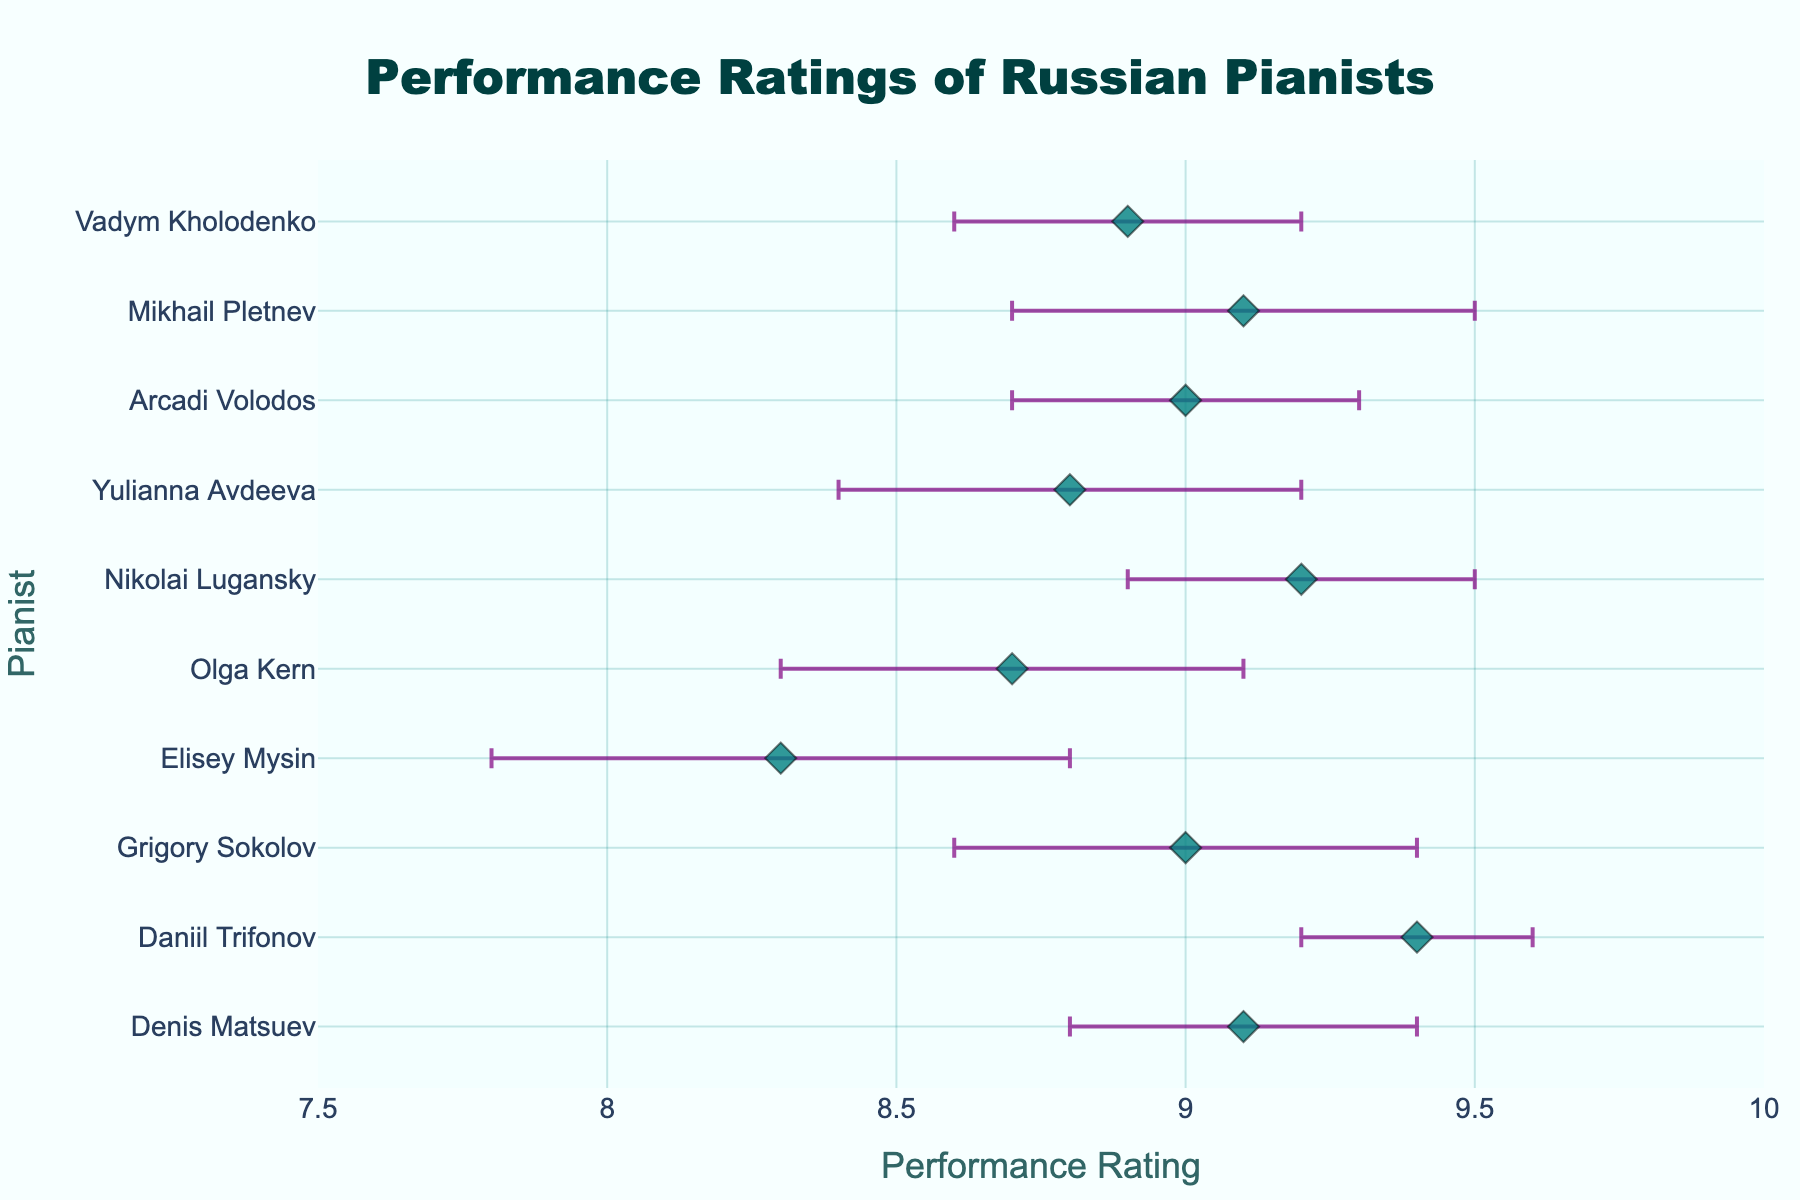What is the highest performance rating shown in the plot? The highest rating is the dot positioned farthest to the right on the x-axis. This corresponds to Daniil Trifonov with a performance rating of 9.4.
Answer: 9.4 Which pianist received the lowest performance rating? The dot farthest to the left on the x-axis indicates the lowest performance rating. This corresponds to Elisey Mysin, who has a performance rating of 8.3.
Answer: Elisey Mysin How many pianists have a performance rating above 9.0? By counting the dots to the right of the 9.0 mark on the x-axis, there are 6 pianists with ratings above 9.0: Denis Matsuev, Daniil Trifonov, Grigory Sokolov, Nikolai Lugansky, Arcadi Volodos, and Mikhail Pletnev.
Answer: 6 Who has the smallest standard deviation in their performance rating? The smallest standard deviation corresponds to the smallest error bar. This is seen with Daniil Trifonov, who has an error bar of 0.2.
Answer: Daniil Trifonov What is the range of performance ratings displayed in the plot? The range is calculated by subtracting the lowest rating (8.3 from Elisey Mysin) from the highest rating (9.4 from Daniil Trifonov), giving 9.4 - 8.3 = 1.1.
Answer: 1.1 Compare the performance ratings of Denis Matsuev and Nikolai Lugansky. Which pianist has a higher rating, and by how much? Denis Matsuev has a rating of 9.1 and Nikolai Lugansky has a rating of 9.2. The difference is 9.2 - 9.1 = 0.1.
Answer: Nikolai Lugansky, by 0.1 Which pianist has the highest variability in performance rating? Highest variability corresponds to the longest error bar. Elisey Mysin has the longest error bar with a standard deviation of 0.5.
Answer: Elisey Mysin What is the average performance rating of the pianists? Sum all performance ratings: (9.1 + 9.4 + 9.0 + 8.3 + 8.7 + 9.2 + 8.8 + 9.0 + 9.1 + 8.9) = 89.5. Then, divide by the number of pianists, which is 10. 89.5 / 10 = 8.95.
Answer: 8.95 